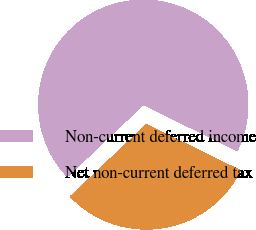Convert chart. <chart><loc_0><loc_0><loc_500><loc_500><pie_chart><fcel>Non-current deferred income<fcel>Net non-current deferred tax<nl><fcel>69.32%<fcel>30.68%<nl></chart> 